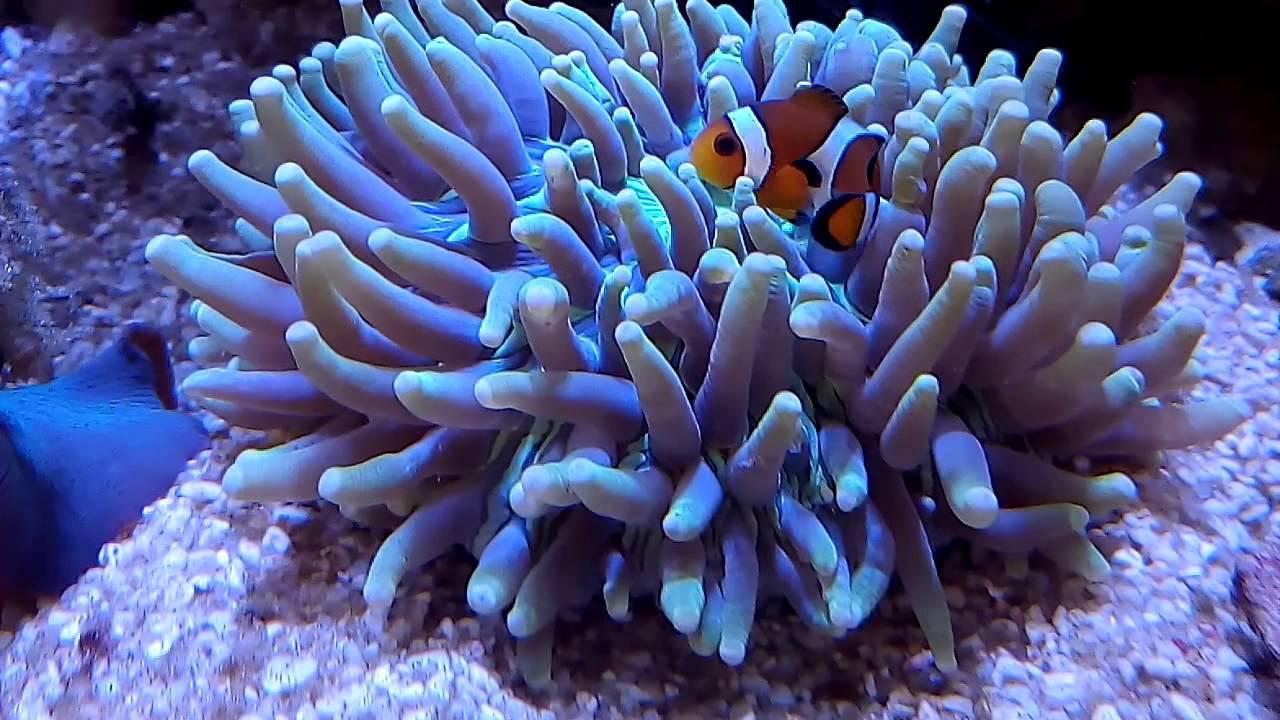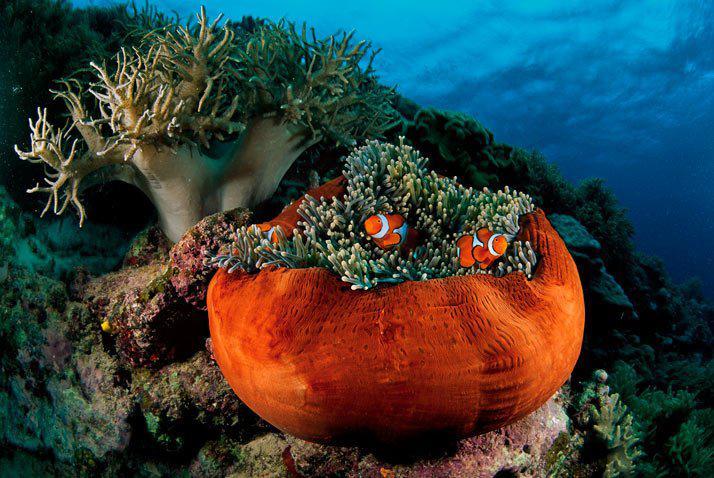The first image is the image on the left, the second image is the image on the right. For the images shown, is this caption "there is only clownfish on the right image" true? Answer yes or no. No. 